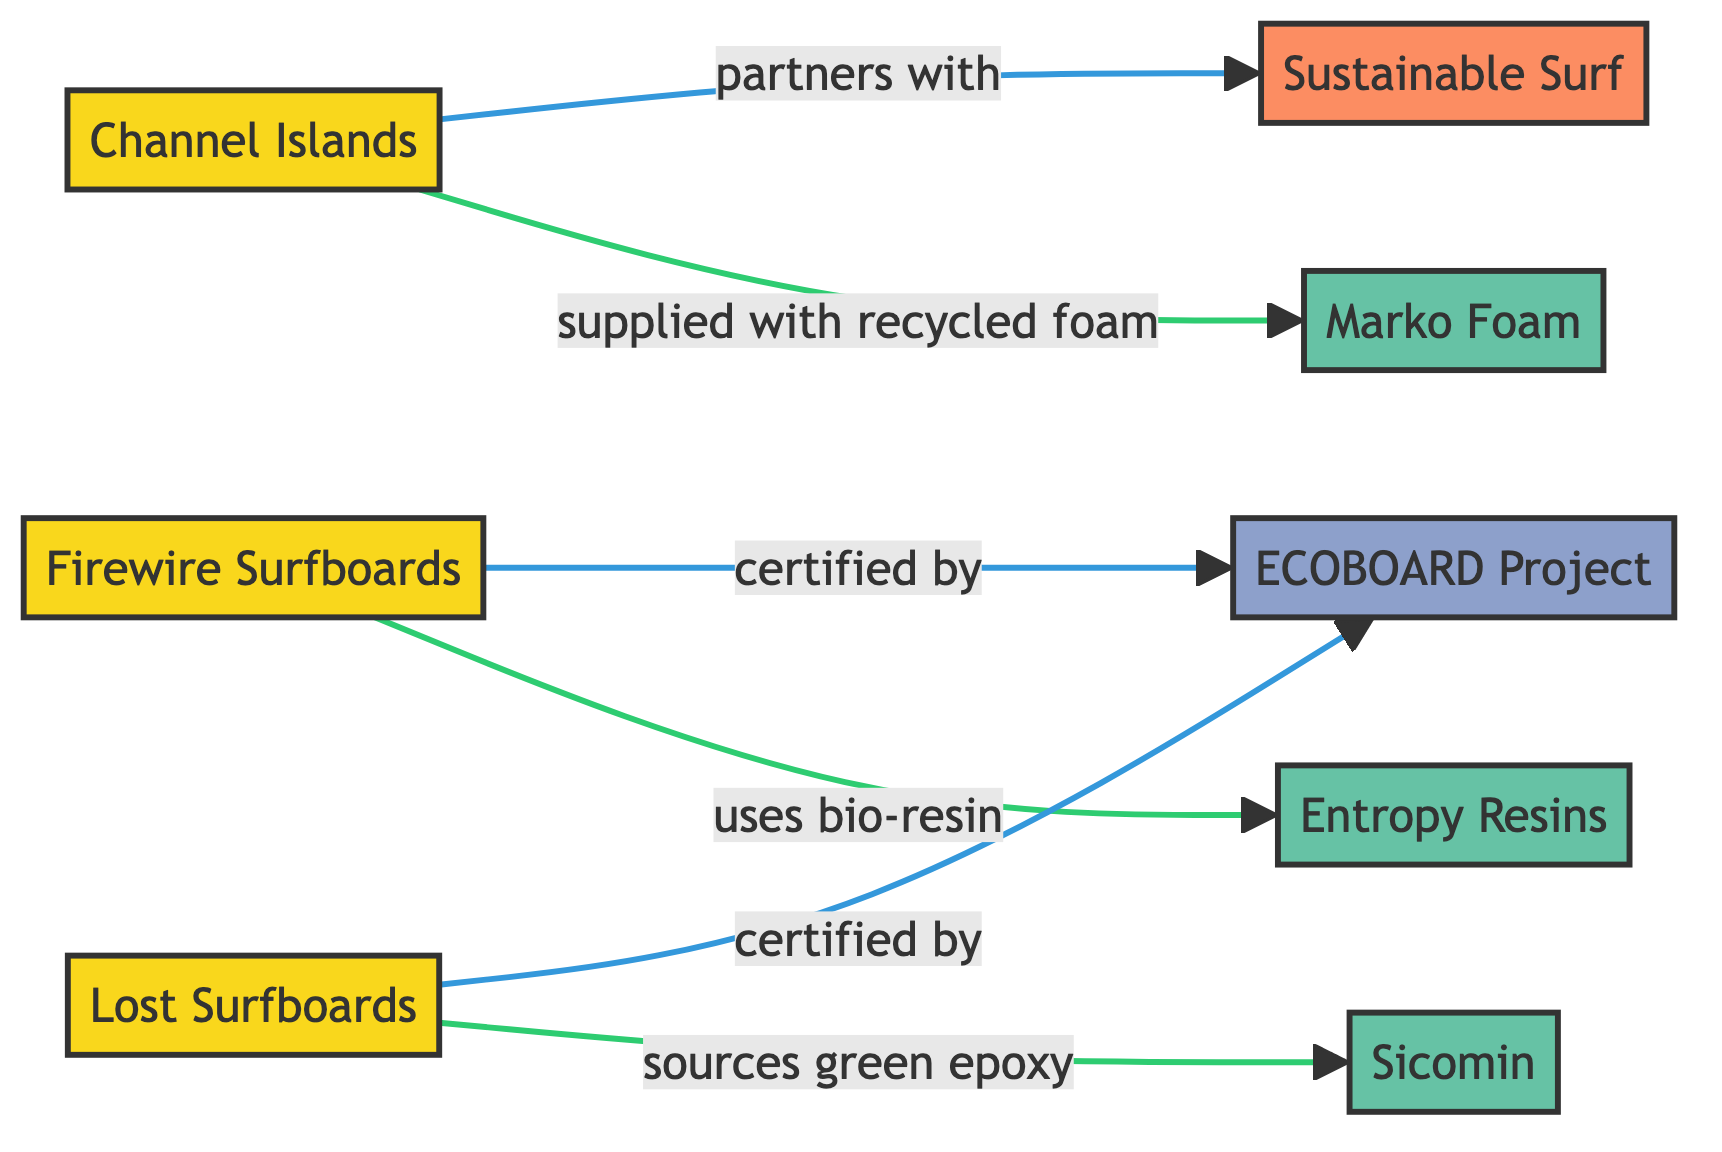What are the surfboard manufacturers listed in the diagram? The diagram shows three surfboard manufacturers: Firewire Surfboards, Channel Islands, and Lost Surfboards. This information can be directly extracted from the nodes labeled as manufacturers.
Answer: Firewire Surfboards, Channel Islands, Lost Surfboards How many eco-friendly material suppliers are in the network? The diagram contains three eco-friendly material suppliers: Entropy Resins, Marko Foam, and Sicomin. This information is found in the nodes specifically identified as material suppliers.
Answer: 3 Which surfboard manufacturer is certified by the ECOBOARD Project? Two surfboard manufacturers are certified by the ECOBOARD Project: Firewire Surfboards and Lost Surfboards. This is determined by checking the edges connecting these manufacturers to the node labeled ECOBOARD Project.
Answer: Firewire Surfboards, Lost Surfboards What type of material does Channel Islands source from Marko Foam? Channel Islands is supplied with recycled foam from Marko Foam, as indicated by the edge labeled "supplied with recycled foam" between these two nodes.
Answer: recycled foam Which surfboard manufacturer uses bio-resin? The surfboard manufacturer Firewire Surfboards uses bio-resin, as indicated by the edge labeled "uses bio-resin" that connects it to Entropy Resins.
Answer: Firewire Surfboards Name a recycling partner for Channel Islands. Channel Islands partners with Sustainable Surf, which is identified as a recycling partner in the edge connecting these two nodes.
Answer: Sustainable Surf Which material supplier is associated with Lost Surfboards? Lost Surfboards sources green epoxy from Sicomin, as shown in the edge connecting Lost Surfboards to Sicomin with the label "sources green epoxy."
Answer: Sicomin How many total edges are there in the network? The network contains a total of five edges, which represent the relationships between the surfboard manufacturers, material suppliers, and other partners. This total can be counted from the connections in the network diagram.
Answer: 5 What is the relationship between Firewire Surfboards and the ECOBOARD Project? Firewire Surfboards has the relationship of being "certified by" the ECOBOARD Project, indicated by the edge connecting these two nodes with that specific label.
Answer: certified by 